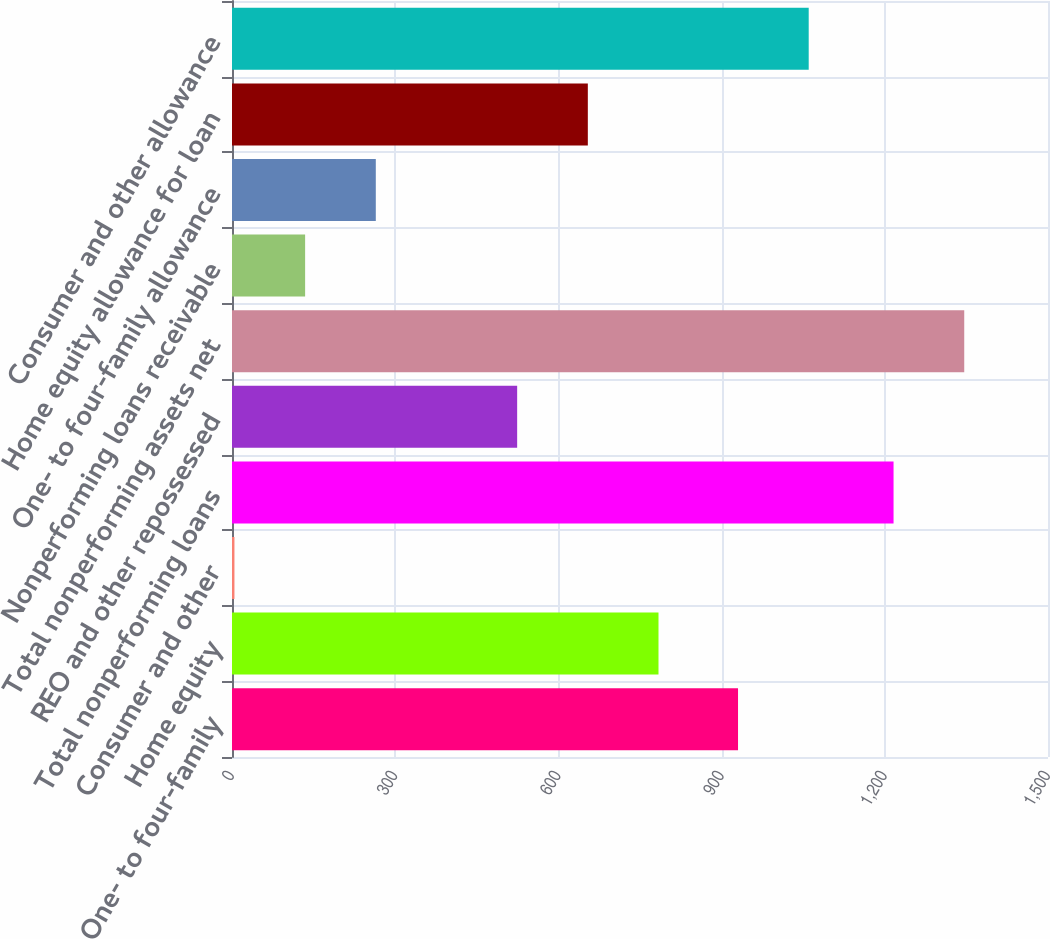Convert chart. <chart><loc_0><loc_0><loc_500><loc_500><bar_chart><fcel>One- to four-family<fcel>Home equity<fcel>Consumer and other<fcel>Total nonperforming loans<fcel>REO and other repossessed<fcel>Total nonperforming assets net<fcel>Nonperforming loans receivable<fcel>One- to four-family allowance<fcel>Home equity allowance for loan<fcel>Consumer and other allowance<nl><fcel>930.2<fcel>784.02<fcel>4.5<fcel>1216.1<fcel>524.18<fcel>1346.02<fcel>134.42<fcel>264.34<fcel>654.1<fcel>1060.12<nl></chart> 